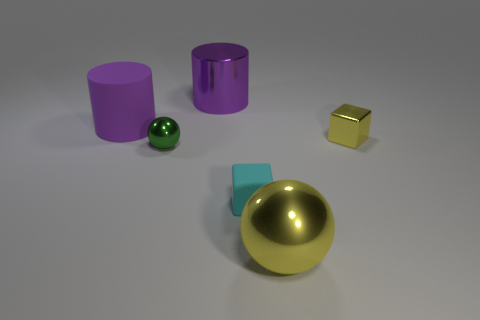Is there a purple metal object that is to the left of the small green metal object in front of the small thing behind the tiny green metal object?
Offer a terse response. No. Is the shape of the small shiny object to the right of the yellow metallic ball the same as  the small cyan rubber object?
Offer a terse response. Yes. The matte thing behind the yellow shiny object that is behind the yellow shiny ball is what shape?
Make the answer very short. Cylinder. What is the size of the metallic object behind the yellow metallic thing that is behind the yellow metal sphere that is left of the metal block?
Keep it short and to the point. Large. What color is the other big shiny thing that is the same shape as the green metal object?
Ensure brevity in your answer.  Yellow. Do the yellow shiny cube and the rubber cylinder have the same size?
Provide a succinct answer. No. There is a purple thing that is left of the green metallic thing; what material is it?
Keep it short and to the point. Rubber. What number of other things are there of the same shape as the cyan rubber thing?
Your answer should be very brief. 1. Is the shape of the cyan thing the same as the tiny green metal object?
Offer a very short reply. No. There is a yellow ball; are there any things on the left side of it?
Provide a succinct answer. Yes. 